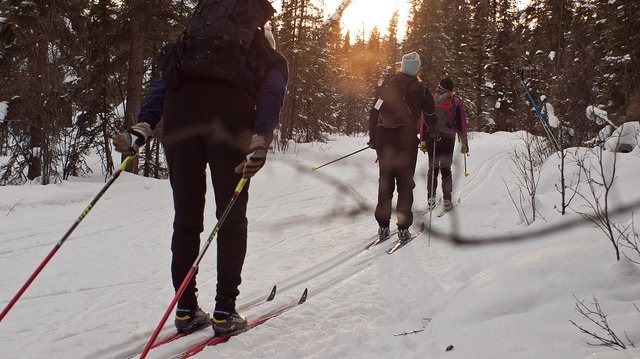Describe the objects in this image and their specific colors. I can see people in black, maroon, darkgray, and lightgray tones, backpack in black, gray, and maroon tones, people in black, maroon, gray, and darkgray tones, people in black, maroon, gray, and darkgray tones, and backpack in black, maroon, and darkgray tones in this image. 